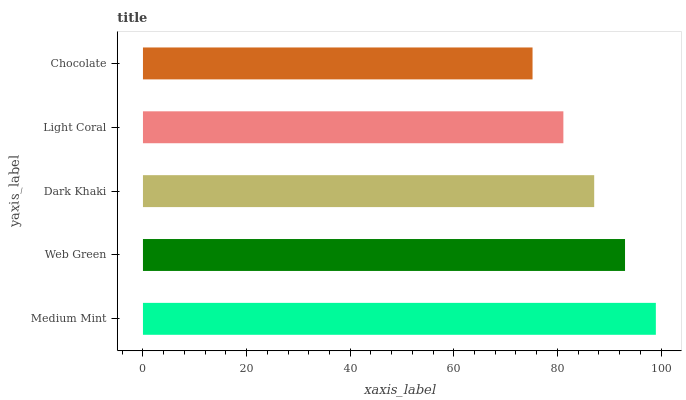Is Chocolate the minimum?
Answer yes or no. Yes. Is Medium Mint the maximum?
Answer yes or no. Yes. Is Web Green the minimum?
Answer yes or no. No. Is Web Green the maximum?
Answer yes or no. No. Is Medium Mint greater than Web Green?
Answer yes or no. Yes. Is Web Green less than Medium Mint?
Answer yes or no. Yes. Is Web Green greater than Medium Mint?
Answer yes or no. No. Is Medium Mint less than Web Green?
Answer yes or no. No. Is Dark Khaki the high median?
Answer yes or no. Yes. Is Dark Khaki the low median?
Answer yes or no. Yes. Is Chocolate the high median?
Answer yes or no. No. Is Web Green the low median?
Answer yes or no. No. 